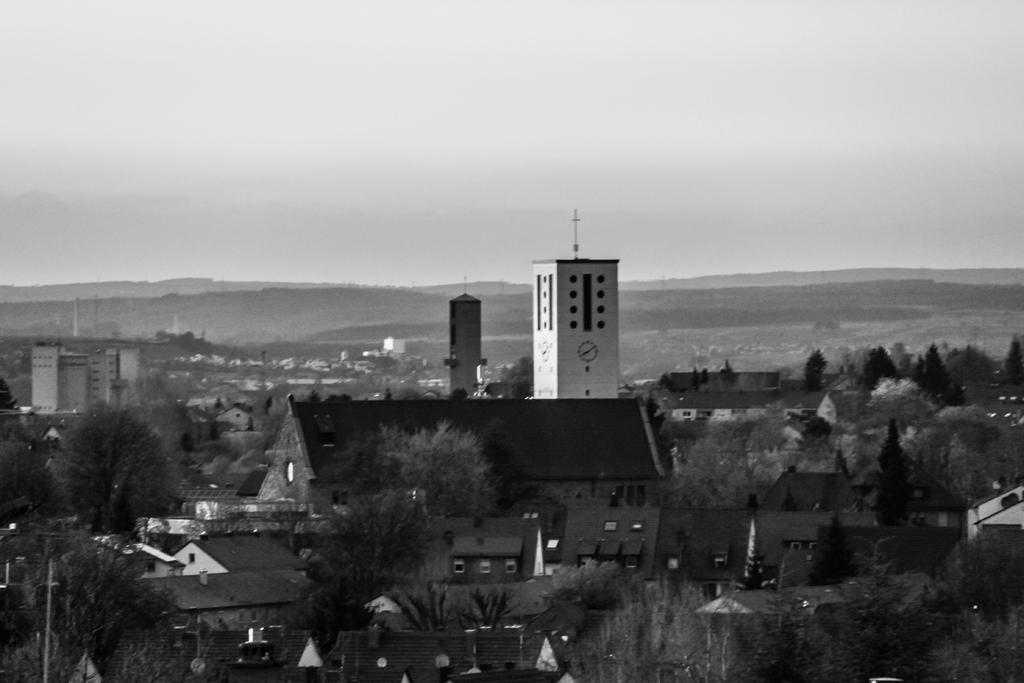What type of natural elements can be seen in the image? There are trees in the image. What type of man-made structures can be seen in the image? There are buildings in the image. What is visible in the background of the image? The sky is visible in the background of the image. What type of music can be heard coming from the sign in the image? There is no sign present in the image, and therefore no music can be heard coming from it. 